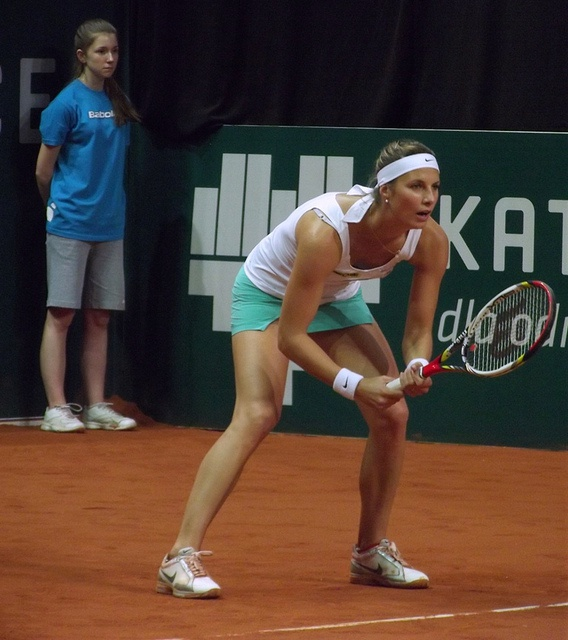Describe the objects in this image and their specific colors. I can see people in black, maroon, gray, brown, and tan tones, people in black, gray, blue, and darkblue tones, and tennis racket in black, gray, darkgray, and maroon tones in this image. 